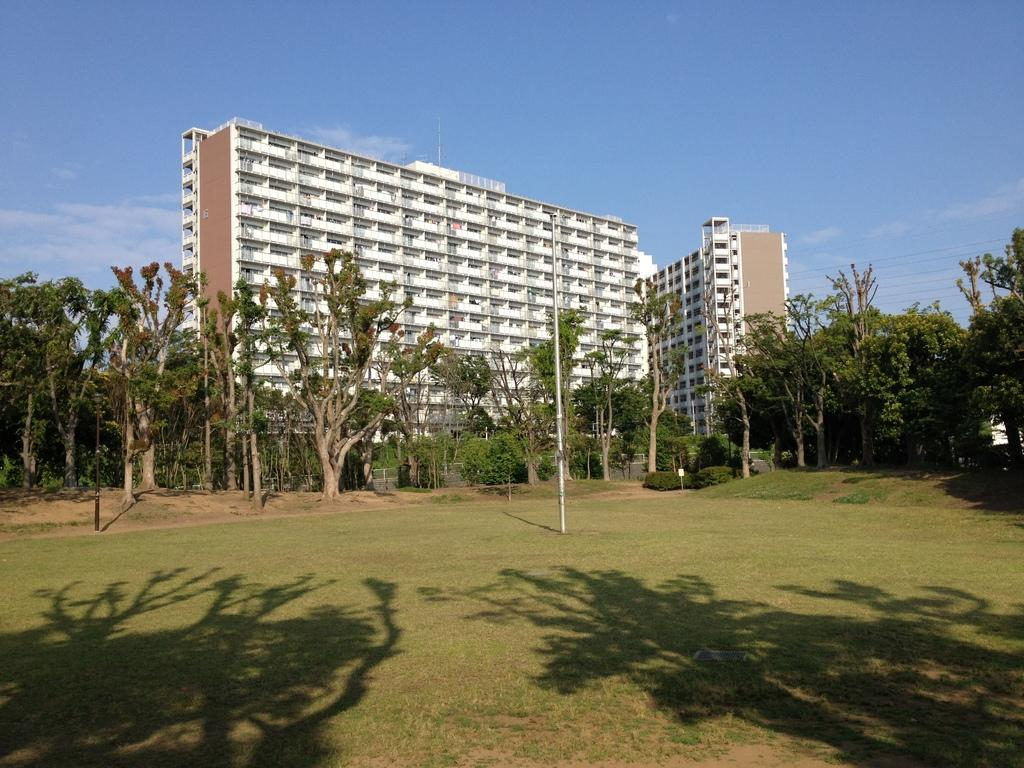What type of terrain is visible in the foreground of the image? There is grassland in the foreground of the image. What can be seen casting shadows in the foreground? There are shadows of trees in the foreground. What object is present in the foreground? There is a pole in the foreground. What type of vegetation is present in the foreground? There are trees in the foreground. What structures can be seen in the background of the image? There are buildings in the background of the image. What part of the natural environment is visible in the background? The sky is visible in the background. Can you describe the sky in the image? There is a cloud in the sky. How does the grassland attack the trees in the image? The grassland does not attack the trees in the image; it is a static terrain feature. 